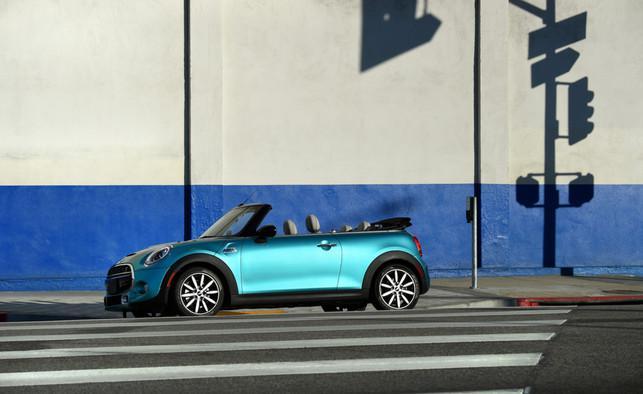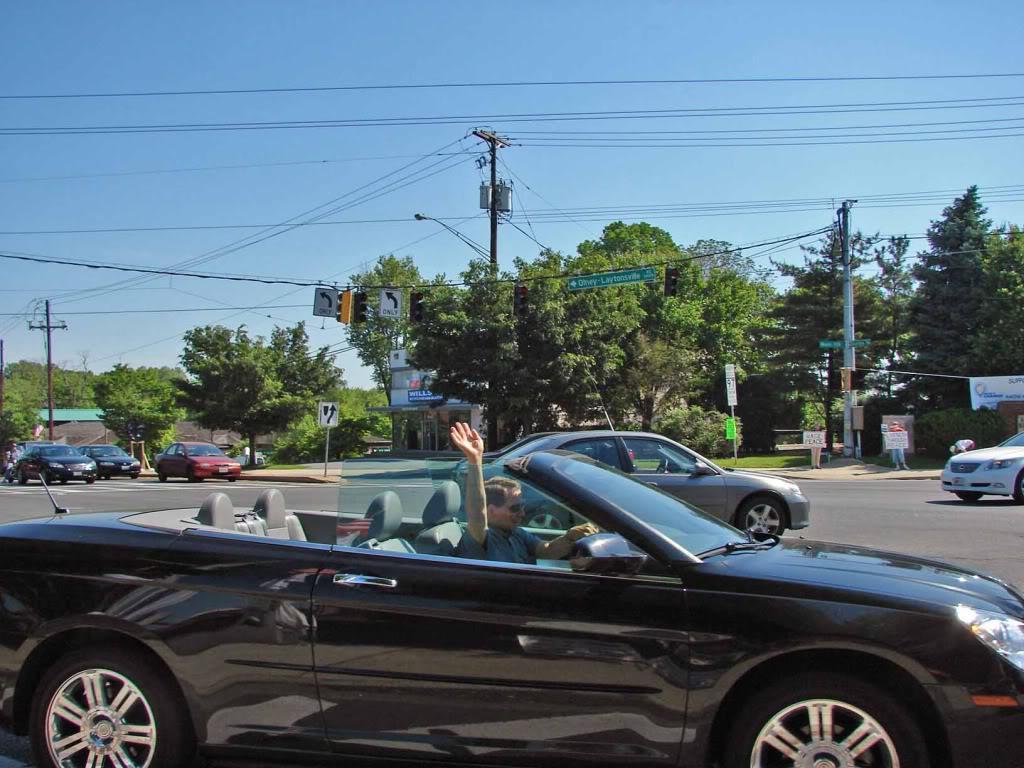The first image is the image on the left, the second image is the image on the right. For the images shown, is this caption "In both images the car has it's top down." true? Answer yes or no. Yes. 